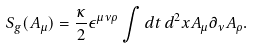Convert formula to latex. <formula><loc_0><loc_0><loc_500><loc_500>S _ { g } ( A _ { \mu } ) = \frac { \kappa } { 2 } \epsilon ^ { \mu \nu \rho } \int d t \, d ^ { 2 } x A _ { \mu } \partial _ { \nu } A _ { \rho } .</formula> 